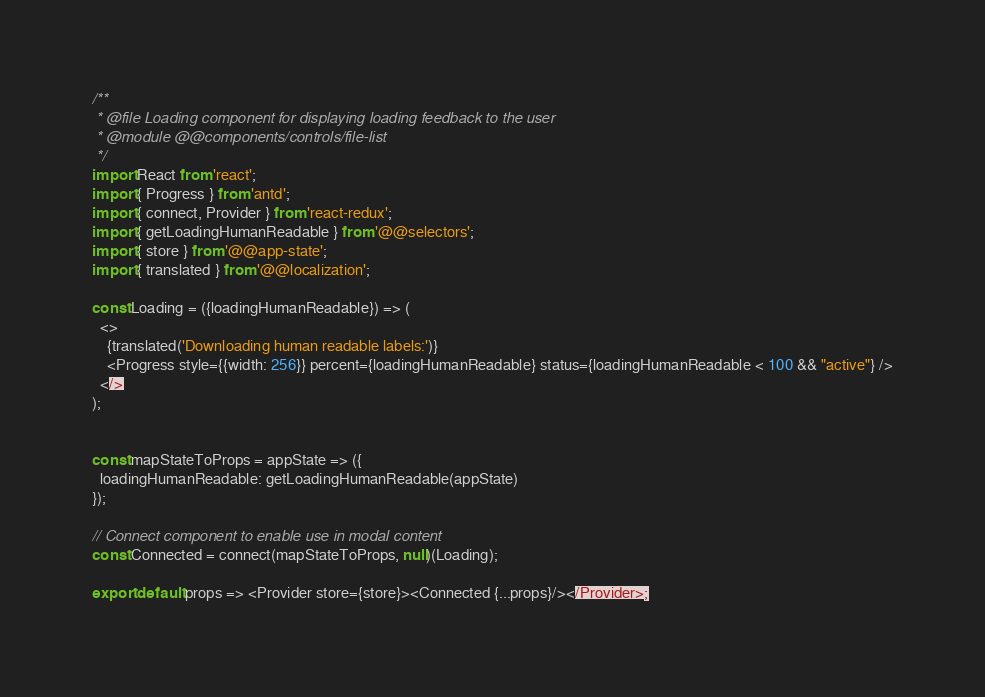<code> <loc_0><loc_0><loc_500><loc_500><_JavaScript_>/**
 * @file Loading component for displaying loading feedback to the user
 * @module @@components/controls/file-list
 */
import React from 'react';
import { Progress } from 'antd';
import { connect, Provider } from 'react-redux';
import { getLoadingHumanReadable } from '@@selectors';
import { store } from '@@app-state';
import { translated } from '@@localization';

const Loading = ({loadingHumanReadable}) => (
  <>
    {translated('Downloading human readable labels:')}
    <Progress style={{width: 256}} percent={loadingHumanReadable} status={loadingHumanReadable < 100 && "active"} />
  </>
);


const mapStateToProps = appState => ({
  loadingHumanReadable: getLoadingHumanReadable(appState)
});

// Connect component to enable use in modal content
const Connected = connect(mapStateToProps, null)(Loading);

export default props => <Provider store={store}><Connected {...props}/></Provider>;
</code> 